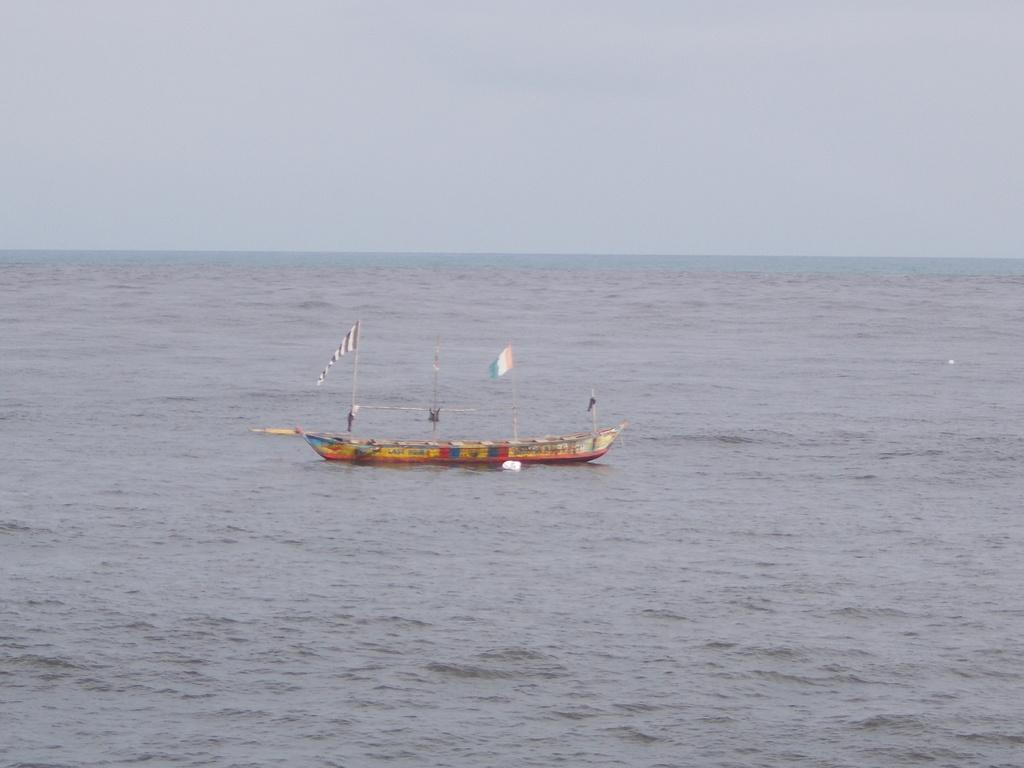Could you give a brief overview of what you see in this image? In this picture we can see a boat in the water, and we can find few flags in the boat. 